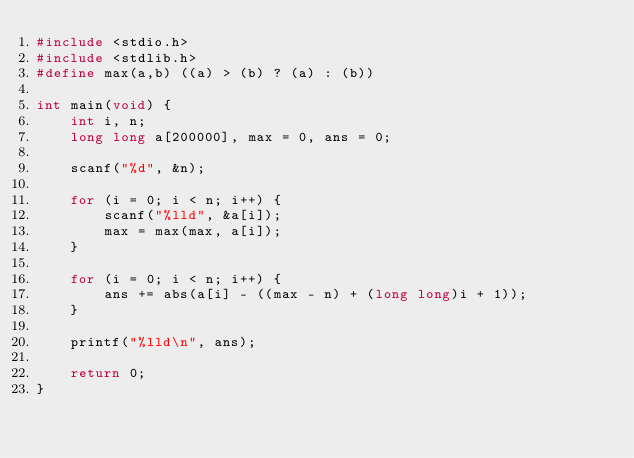Convert code to text. <code><loc_0><loc_0><loc_500><loc_500><_C_>#include <stdio.h>
#include <stdlib.h>
#define max(a,b) ((a) > (b) ? (a) : (b))

int main(void) {
	int i, n;
	long long a[200000], max = 0, ans = 0;
	
	scanf("%d", &n);
	
	for (i = 0; i < n; i++) {
		scanf("%lld", &a[i]);
		max = max(max, a[i]);
	}
	
	for (i = 0; i < n; i++) {
		ans += abs(a[i] - ((max - n) + (long long)i + 1));
	}
	
	printf("%lld\n", ans);
	
	return 0;
}</code> 